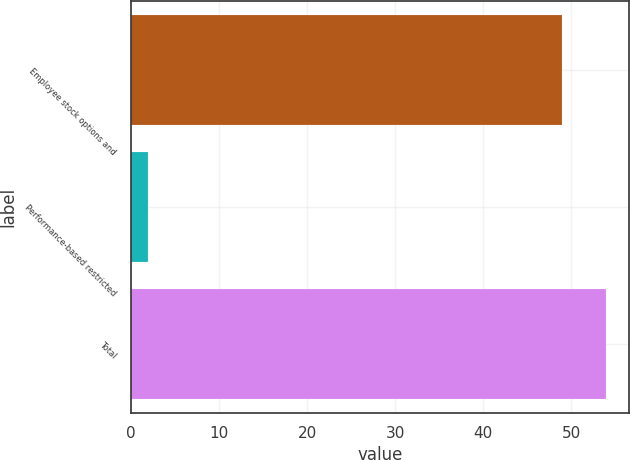Convert chart to OTSL. <chart><loc_0><loc_0><loc_500><loc_500><bar_chart><fcel>Employee stock options and<fcel>Performance-based restricted<fcel>Total<nl><fcel>49<fcel>2<fcel>53.9<nl></chart> 